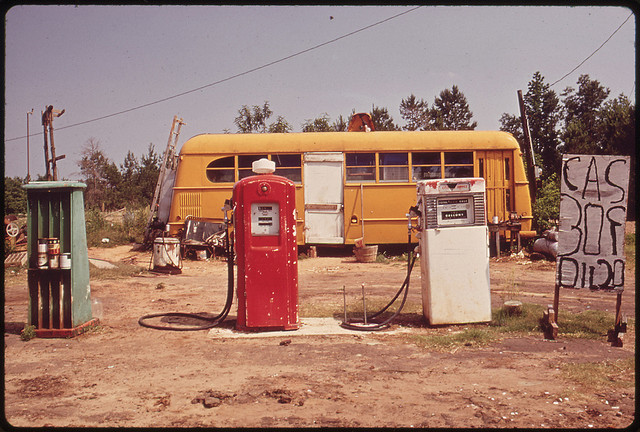Please transcribe the text in this image. BOI DIDO CAS 